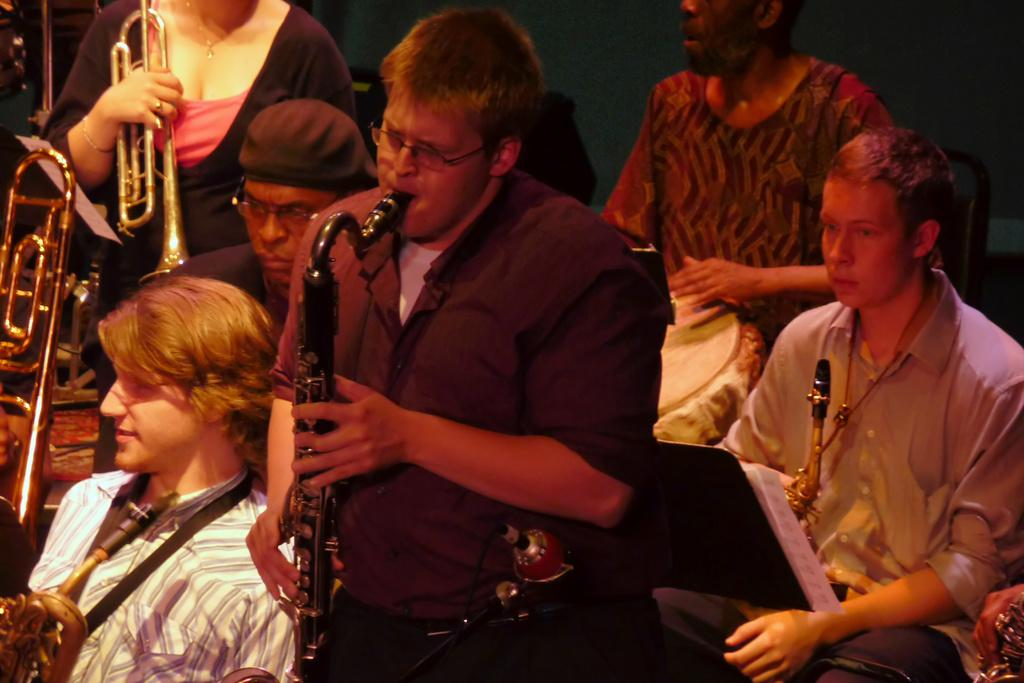Who or what can be seen in the image? There are people in the image. What objects are associated with the people in the image? There are saxophones in the image. What scientific experiment is being conducted in the image? There is no scientific experiment visible in the image; it features people and saxophones. What type of leaf can be seen falling from the sky in the image? There are no leaves or any indication of a sky in the image; it only shows people and saxophones. 